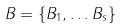<formula> <loc_0><loc_0><loc_500><loc_500>B = \{ B _ { 1 } , \dots B _ { s } \}</formula> 